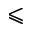<formula> <loc_0><loc_0><loc_500><loc_500>\leqslant</formula> 